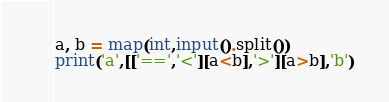Convert code to text. <code><loc_0><loc_0><loc_500><loc_500><_Python_>a, b = map(int,input().split())
print('a',[['==','<'][a<b],'>'][a>b],'b')
</code> 